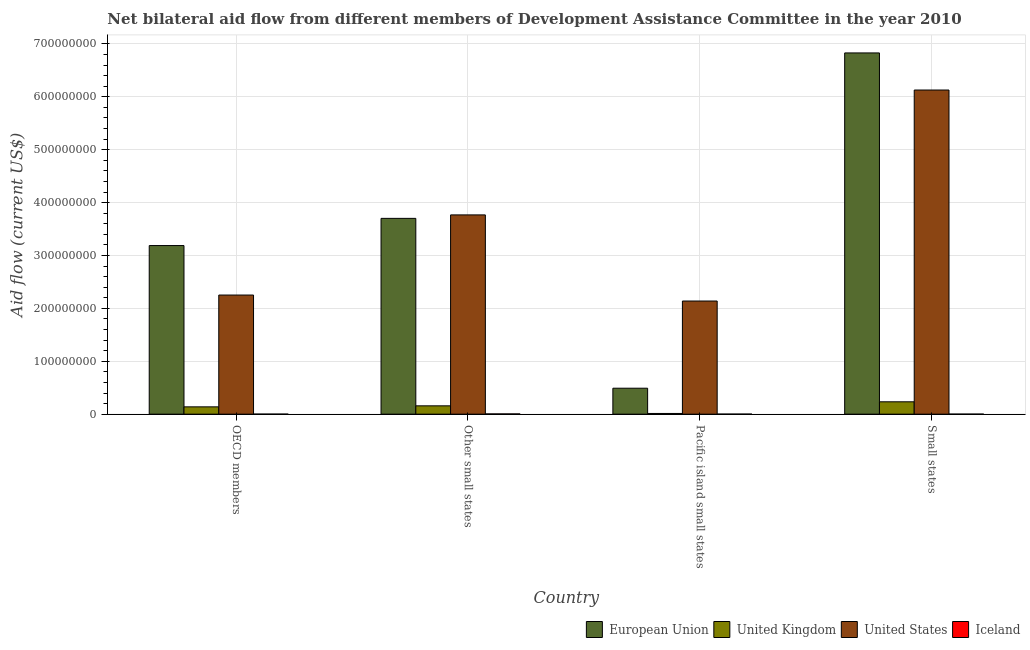How many different coloured bars are there?
Your answer should be compact. 4. How many groups of bars are there?
Ensure brevity in your answer.  4. Are the number of bars per tick equal to the number of legend labels?
Your answer should be compact. Yes. How many bars are there on the 2nd tick from the left?
Keep it short and to the point. 4. How many bars are there on the 2nd tick from the right?
Offer a terse response. 4. What is the label of the 4th group of bars from the left?
Your answer should be very brief. Small states. What is the amount of aid given by us in Pacific island small states?
Offer a very short reply. 2.14e+08. Across all countries, what is the maximum amount of aid given by us?
Ensure brevity in your answer.  6.13e+08. Across all countries, what is the minimum amount of aid given by uk?
Your answer should be compact. 1.34e+06. In which country was the amount of aid given by iceland maximum?
Make the answer very short. Other small states. In which country was the amount of aid given by uk minimum?
Your response must be concise. Pacific island small states. What is the total amount of aid given by uk in the graph?
Keep it short and to the point. 5.43e+07. What is the difference between the amount of aid given by uk in Pacific island small states and that in Small states?
Provide a short and direct response. -2.20e+07. What is the difference between the amount of aid given by us in Small states and the amount of aid given by eu in Pacific island small states?
Provide a short and direct response. 5.64e+08. What is the difference between the amount of aid given by eu and amount of aid given by uk in OECD members?
Give a very brief answer. 3.05e+08. What is the ratio of the amount of aid given by iceland in OECD members to that in Pacific island small states?
Make the answer very short. 0.67. What is the difference between the highest and the second highest amount of aid given by uk?
Give a very brief answer. 7.62e+06. What is the difference between the highest and the lowest amount of aid given by uk?
Offer a very short reply. 2.20e+07. In how many countries, is the amount of aid given by iceland greater than the average amount of aid given by iceland taken over all countries?
Provide a succinct answer. 1. Is the sum of the amount of aid given by iceland in OECD members and Small states greater than the maximum amount of aid given by uk across all countries?
Your answer should be very brief. No. What does the 2nd bar from the right in Other small states represents?
Make the answer very short. United States. Is it the case that in every country, the sum of the amount of aid given by eu and amount of aid given by uk is greater than the amount of aid given by us?
Make the answer very short. No. Are all the bars in the graph horizontal?
Provide a short and direct response. No. Are the values on the major ticks of Y-axis written in scientific E-notation?
Ensure brevity in your answer.  No. Does the graph contain any zero values?
Provide a short and direct response. No. Where does the legend appear in the graph?
Make the answer very short. Bottom right. What is the title of the graph?
Give a very brief answer. Net bilateral aid flow from different members of Development Assistance Committee in the year 2010. Does "Negligence towards children" appear as one of the legend labels in the graph?
Offer a very short reply. No. What is the label or title of the Y-axis?
Make the answer very short. Aid flow (current US$). What is the Aid flow (current US$) in European Union in OECD members?
Ensure brevity in your answer.  3.19e+08. What is the Aid flow (current US$) in United Kingdom in OECD members?
Your response must be concise. 1.38e+07. What is the Aid flow (current US$) in United States in OECD members?
Make the answer very short. 2.25e+08. What is the Aid flow (current US$) in European Union in Other small states?
Provide a short and direct response. 3.70e+08. What is the Aid flow (current US$) in United Kingdom in Other small states?
Keep it short and to the point. 1.57e+07. What is the Aid flow (current US$) in United States in Other small states?
Your response must be concise. 3.77e+08. What is the Aid flow (current US$) of European Union in Pacific island small states?
Your answer should be very brief. 4.91e+07. What is the Aid flow (current US$) in United Kingdom in Pacific island small states?
Your response must be concise. 1.34e+06. What is the Aid flow (current US$) of United States in Pacific island small states?
Your answer should be compact. 2.14e+08. What is the Aid flow (current US$) of European Union in Small states?
Provide a short and direct response. 6.83e+08. What is the Aid flow (current US$) of United Kingdom in Small states?
Offer a terse response. 2.34e+07. What is the Aid flow (current US$) of United States in Small states?
Make the answer very short. 6.13e+08. What is the Aid flow (current US$) of Iceland in Small states?
Your response must be concise. 9.00e+04. Across all countries, what is the maximum Aid flow (current US$) in European Union?
Give a very brief answer. 6.83e+08. Across all countries, what is the maximum Aid flow (current US$) of United Kingdom?
Ensure brevity in your answer.  2.34e+07. Across all countries, what is the maximum Aid flow (current US$) of United States?
Provide a short and direct response. 6.13e+08. Across all countries, what is the maximum Aid flow (current US$) in Iceland?
Give a very brief answer. 4.70e+05. Across all countries, what is the minimum Aid flow (current US$) of European Union?
Offer a very short reply. 4.91e+07. Across all countries, what is the minimum Aid flow (current US$) in United Kingdom?
Offer a very short reply. 1.34e+06. Across all countries, what is the minimum Aid flow (current US$) of United States?
Provide a succinct answer. 2.14e+08. What is the total Aid flow (current US$) in European Union in the graph?
Make the answer very short. 1.42e+09. What is the total Aid flow (current US$) in United Kingdom in the graph?
Make the answer very short. 5.43e+07. What is the total Aid flow (current US$) in United States in the graph?
Offer a terse response. 1.43e+09. What is the total Aid flow (current US$) in Iceland in the graph?
Keep it short and to the point. 7.60e+05. What is the difference between the Aid flow (current US$) in European Union in OECD members and that in Other small states?
Your answer should be very brief. -5.14e+07. What is the difference between the Aid flow (current US$) in United Kingdom in OECD members and that in Other small states?
Your response must be concise. -1.92e+06. What is the difference between the Aid flow (current US$) of United States in OECD members and that in Other small states?
Give a very brief answer. -1.52e+08. What is the difference between the Aid flow (current US$) of Iceland in OECD members and that in Other small states?
Keep it short and to the point. -3.90e+05. What is the difference between the Aid flow (current US$) of European Union in OECD members and that in Pacific island small states?
Provide a short and direct response. 2.70e+08. What is the difference between the Aid flow (current US$) of United Kingdom in OECD members and that in Pacific island small states?
Keep it short and to the point. 1.25e+07. What is the difference between the Aid flow (current US$) of United States in OECD members and that in Pacific island small states?
Give a very brief answer. 1.13e+07. What is the difference between the Aid flow (current US$) of Iceland in OECD members and that in Pacific island small states?
Provide a short and direct response. -4.00e+04. What is the difference between the Aid flow (current US$) of European Union in OECD members and that in Small states?
Offer a very short reply. -3.64e+08. What is the difference between the Aid flow (current US$) in United Kingdom in OECD members and that in Small states?
Make the answer very short. -9.54e+06. What is the difference between the Aid flow (current US$) in United States in OECD members and that in Small states?
Offer a very short reply. -3.88e+08. What is the difference between the Aid flow (current US$) of European Union in Other small states and that in Pacific island small states?
Make the answer very short. 3.21e+08. What is the difference between the Aid flow (current US$) of United Kingdom in Other small states and that in Pacific island small states?
Offer a terse response. 1.44e+07. What is the difference between the Aid flow (current US$) in United States in Other small states and that in Pacific island small states?
Give a very brief answer. 1.63e+08. What is the difference between the Aid flow (current US$) in European Union in Other small states and that in Small states?
Offer a terse response. -3.13e+08. What is the difference between the Aid flow (current US$) in United Kingdom in Other small states and that in Small states?
Give a very brief answer. -7.62e+06. What is the difference between the Aid flow (current US$) of United States in Other small states and that in Small states?
Your answer should be very brief. -2.36e+08. What is the difference between the Aid flow (current US$) of Iceland in Other small states and that in Small states?
Ensure brevity in your answer.  3.80e+05. What is the difference between the Aid flow (current US$) of European Union in Pacific island small states and that in Small states?
Provide a short and direct response. -6.34e+08. What is the difference between the Aid flow (current US$) of United Kingdom in Pacific island small states and that in Small states?
Your answer should be compact. -2.20e+07. What is the difference between the Aid flow (current US$) of United States in Pacific island small states and that in Small states?
Offer a terse response. -3.99e+08. What is the difference between the Aid flow (current US$) of European Union in OECD members and the Aid flow (current US$) of United Kingdom in Other small states?
Provide a succinct answer. 3.03e+08. What is the difference between the Aid flow (current US$) in European Union in OECD members and the Aid flow (current US$) in United States in Other small states?
Offer a very short reply. -5.80e+07. What is the difference between the Aid flow (current US$) in European Union in OECD members and the Aid flow (current US$) in Iceland in Other small states?
Ensure brevity in your answer.  3.18e+08. What is the difference between the Aid flow (current US$) of United Kingdom in OECD members and the Aid flow (current US$) of United States in Other small states?
Give a very brief answer. -3.63e+08. What is the difference between the Aid flow (current US$) in United Kingdom in OECD members and the Aid flow (current US$) in Iceland in Other small states?
Make the answer very short. 1.34e+07. What is the difference between the Aid flow (current US$) of United States in OECD members and the Aid flow (current US$) of Iceland in Other small states?
Your response must be concise. 2.25e+08. What is the difference between the Aid flow (current US$) of European Union in OECD members and the Aid flow (current US$) of United Kingdom in Pacific island small states?
Ensure brevity in your answer.  3.17e+08. What is the difference between the Aid flow (current US$) in European Union in OECD members and the Aid flow (current US$) in United States in Pacific island small states?
Offer a very short reply. 1.05e+08. What is the difference between the Aid flow (current US$) in European Union in OECD members and the Aid flow (current US$) in Iceland in Pacific island small states?
Your answer should be compact. 3.19e+08. What is the difference between the Aid flow (current US$) of United Kingdom in OECD members and the Aid flow (current US$) of United States in Pacific island small states?
Your answer should be very brief. -2.00e+08. What is the difference between the Aid flow (current US$) of United Kingdom in OECD members and the Aid flow (current US$) of Iceland in Pacific island small states?
Make the answer very short. 1.37e+07. What is the difference between the Aid flow (current US$) in United States in OECD members and the Aid flow (current US$) in Iceland in Pacific island small states?
Your response must be concise. 2.25e+08. What is the difference between the Aid flow (current US$) in European Union in OECD members and the Aid flow (current US$) in United Kingdom in Small states?
Your response must be concise. 2.95e+08. What is the difference between the Aid flow (current US$) in European Union in OECD members and the Aid flow (current US$) in United States in Small states?
Your answer should be very brief. -2.94e+08. What is the difference between the Aid flow (current US$) of European Union in OECD members and the Aid flow (current US$) of Iceland in Small states?
Offer a very short reply. 3.19e+08. What is the difference between the Aid flow (current US$) in United Kingdom in OECD members and the Aid flow (current US$) in United States in Small states?
Your answer should be compact. -5.99e+08. What is the difference between the Aid flow (current US$) in United Kingdom in OECD members and the Aid flow (current US$) in Iceland in Small states?
Your answer should be compact. 1.37e+07. What is the difference between the Aid flow (current US$) in United States in OECD members and the Aid flow (current US$) in Iceland in Small states?
Make the answer very short. 2.25e+08. What is the difference between the Aid flow (current US$) of European Union in Other small states and the Aid flow (current US$) of United Kingdom in Pacific island small states?
Ensure brevity in your answer.  3.69e+08. What is the difference between the Aid flow (current US$) in European Union in Other small states and the Aid flow (current US$) in United States in Pacific island small states?
Make the answer very short. 1.56e+08. What is the difference between the Aid flow (current US$) of European Union in Other small states and the Aid flow (current US$) of Iceland in Pacific island small states?
Provide a succinct answer. 3.70e+08. What is the difference between the Aid flow (current US$) of United Kingdom in Other small states and the Aid flow (current US$) of United States in Pacific island small states?
Provide a short and direct response. -1.98e+08. What is the difference between the Aid flow (current US$) in United Kingdom in Other small states and the Aid flow (current US$) in Iceland in Pacific island small states?
Offer a terse response. 1.56e+07. What is the difference between the Aid flow (current US$) in United States in Other small states and the Aid flow (current US$) in Iceland in Pacific island small states?
Keep it short and to the point. 3.77e+08. What is the difference between the Aid flow (current US$) of European Union in Other small states and the Aid flow (current US$) of United Kingdom in Small states?
Provide a succinct answer. 3.47e+08. What is the difference between the Aid flow (current US$) of European Union in Other small states and the Aid flow (current US$) of United States in Small states?
Give a very brief answer. -2.43e+08. What is the difference between the Aid flow (current US$) of European Union in Other small states and the Aid flow (current US$) of Iceland in Small states?
Offer a terse response. 3.70e+08. What is the difference between the Aid flow (current US$) of United Kingdom in Other small states and the Aid flow (current US$) of United States in Small states?
Offer a terse response. -5.97e+08. What is the difference between the Aid flow (current US$) in United Kingdom in Other small states and the Aid flow (current US$) in Iceland in Small states?
Make the answer very short. 1.56e+07. What is the difference between the Aid flow (current US$) in United States in Other small states and the Aid flow (current US$) in Iceland in Small states?
Offer a terse response. 3.77e+08. What is the difference between the Aid flow (current US$) in European Union in Pacific island small states and the Aid flow (current US$) in United Kingdom in Small states?
Your answer should be compact. 2.57e+07. What is the difference between the Aid flow (current US$) of European Union in Pacific island small states and the Aid flow (current US$) of United States in Small states?
Provide a succinct answer. -5.64e+08. What is the difference between the Aid flow (current US$) of European Union in Pacific island small states and the Aid flow (current US$) of Iceland in Small states?
Offer a terse response. 4.90e+07. What is the difference between the Aid flow (current US$) in United Kingdom in Pacific island small states and the Aid flow (current US$) in United States in Small states?
Offer a terse response. -6.12e+08. What is the difference between the Aid flow (current US$) of United Kingdom in Pacific island small states and the Aid flow (current US$) of Iceland in Small states?
Provide a succinct answer. 1.25e+06. What is the difference between the Aid flow (current US$) of United States in Pacific island small states and the Aid flow (current US$) of Iceland in Small states?
Give a very brief answer. 2.14e+08. What is the average Aid flow (current US$) of European Union per country?
Offer a terse response. 3.55e+08. What is the average Aid flow (current US$) in United Kingdom per country?
Ensure brevity in your answer.  1.36e+07. What is the average Aid flow (current US$) of United States per country?
Offer a terse response. 3.57e+08. What is the difference between the Aid flow (current US$) in European Union and Aid flow (current US$) in United Kingdom in OECD members?
Make the answer very short. 3.05e+08. What is the difference between the Aid flow (current US$) of European Union and Aid flow (current US$) of United States in OECD members?
Your response must be concise. 9.36e+07. What is the difference between the Aid flow (current US$) in European Union and Aid flow (current US$) in Iceland in OECD members?
Your response must be concise. 3.19e+08. What is the difference between the Aid flow (current US$) of United Kingdom and Aid flow (current US$) of United States in OECD members?
Your answer should be very brief. -2.11e+08. What is the difference between the Aid flow (current US$) of United Kingdom and Aid flow (current US$) of Iceland in OECD members?
Your answer should be very brief. 1.37e+07. What is the difference between the Aid flow (current US$) in United States and Aid flow (current US$) in Iceland in OECD members?
Your response must be concise. 2.25e+08. What is the difference between the Aid flow (current US$) in European Union and Aid flow (current US$) in United Kingdom in Other small states?
Your answer should be compact. 3.54e+08. What is the difference between the Aid flow (current US$) of European Union and Aid flow (current US$) of United States in Other small states?
Make the answer very short. -6.56e+06. What is the difference between the Aid flow (current US$) of European Union and Aid flow (current US$) of Iceland in Other small states?
Keep it short and to the point. 3.70e+08. What is the difference between the Aid flow (current US$) of United Kingdom and Aid flow (current US$) of United States in Other small states?
Your answer should be compact. -3.61e+08. What is the difference between the Aid flow (current US$) in United Kingdom and Aid flow (current US$) in Iceland in Other small states?
Keep it short and to the point. 1.53e+07. What is the difference between the Aid flow (current US$) of United States and Aid flow (current US$) of Iceland in Other small states?
Keep it short and to the point. 3.76e+08. What is the difference between the Aid flow (current US$) in European Union and Aid flow (current US$) in United Kingdom in Pacific island small states?
Keep it short and to the point. 4.77e+07. What is the difference between the Aid flow (current US$) of European Union and Aid flow (current US$) of United States in Pacific island small states?
Your answer should be compact. -1.65e+08. What is the difference between the Aid flow (current US$) in European Union and Aid flow (current US$) in Iceland in Pacific island small states?
Ensure brevity in your answer.  4.89e+07. What is the difference between the Aid flow (current US$) in United Kingdom and Aid flow (current US$) in United States in Pacific island small states?
Offer a very short reply. -2.13e+08. What is the difference between the Aid flow (current US$) of United Kingdom and Aid flow (current US$) of Iceland in Pacific island small states?
Provide a short and direct response. 1.22e+06. What is the difference between the Aid flow (current US$) in United States and Aid flow (current US$) in Iceland in Pacific island small states?
Offer a terse response. 2.14e+08. What is the difference between the Aid flow (current US$) in European Union and Aid flow (current US$) in United Kingdom in Small states?
Your response must be concise. 6.60e+08. What is the difference between the Aid flow (current US$) in European Union and Aid flow (current US$) in United States in Small states?
Offer a very short reply. 7.01e+07. What is the difference between the Aid flow (current US$) of European Union and Aid flow (current US$) of Iceland in Small states?
Provide a succinct answer. 6.83e+08. What is the difference between the Aid flow (current US$) of United Kingdom and Aid flow (current US$) of United States in Small states?
Provide a succinct answer. -5.90e+08. What is the difference between the Aid flow (current US$) in United Kingdom and Aid flow (current US$) in Iceland in Small states?
Keep it short and to the point. 2.33e+07. What is the difference between the Aid flow (current US$) of United States and Aid flow (current US$) of Iceland in Small states?
Provide a succinct answer. 6.13e+08. What is the ratio of the Aid flow (current US$) of European Union in OECD members to that in Other small states?
Ensure brevity in your answer.  0.86. What is the ratio of the Aid flow (current US$) in United Kingdom in OECD members to that in Other small states?
Ensure brevity in your answer.  0.88. What is the ratio of the Aid flow (current US$) of United States in OECD members to that in Other small states?
Give a very brief answer. 0.6. What is the ratio of the Aid flow (current US$) of Iceland in OECD members to that in Other small states?
Your answer should be compact. 0.17. What is the ratio of the Aid flow (current US$) of European Union in OECD members to that in Pacific island small states?
Provide a succinct answer. 6.5. What is the ratio of the Aid flow (current US$) in United Kingdom in OECD members to that in Pacific island small states?
Your answer should be very brief. 10.31. What is the ratio of the Aid flow (current US$) in United States in OECD members to that in Pacific island small states?
Offer a terse response. 1.05. What is the ratio of the Aid flow (current US$) in Iceland in OECD members to that in Pacific island small states?
Provide a succinct answer. 0.67. What is the ratio of the Aid flow (current US$) in European Union in OECD members to that in Small states?
Make the answer very short. 0.47. What is the ratio of the Aid flow (current US$) of United Kingdom in OECD members to that in Small states?
Give a very brief answer. 0.59. What is the ratio of the Aid flow (current US$) of United States in OECD members to that in Small states?
Provide a short and direct response. 0.37. What is the ratio of the Aid flow (current US$) in Iceland in OECD members to that in Small states?
Provide a short and direct response. 0.89. What is the ratio of the Aid flow (current US$) of European Union in Other small states to that in Pacific island small states?
Provide a succinct answer. 7.55. What is the ratio of the Aid flow (current US$) of United Kingdom in Other small states to that in Pacific island small states?
Make the answer very short. 11.75. What is the ratio of the Aid flow (current US$) in United States in Other small states to that in Pacific island small states?
Your answer should be compact. 1.76. What is the ratio of the Aid flow (current US$) of Iceland in Other small states to that in Pacific island small states?
Your answer should be compact. 3.92. What is the ratio of the Aid flow (current US$) of European Union in Other small states to that in Small states?
Ensure brevity in your answer.  0.54. What is the ratio of the Aid flow (current US$) of United Kingdom in Other small states to that in Small states?
Your response must be concise. 0.67. What is the ratio of the Aid flow (current US$) of United States in Other small states to that in Small states?
Keep it short and to the point. 0.61. What is the ratio of the Aid flow (current US$) in Iceland in Other small states to that in Small states?
Offer a very short reply. 5.22. What is the ratio of the Aid flow (current US$) of European Union in Pacific island small states to that in Small states?
Keep it short and to the point. 0.07. What is the ratio of the Aid flow (current US$) of United Kingdom in Pacific island small states to that in Small states?
Offer a very short reply. 0.06. What is the ratio of the Aid flow (current US$) in United States in Pacific island small states to that in Small states?
Offer a terse response. 0.35. What is the ratio of the Aid flow (current US$) of Iceland in Pacific island small states to that in Small states?
Provide a short and direct response. 1.33. What is the difference between the highest and the second highest Aid flow (current US$) of European Union?
Offer a terse response. 3.13e+08. What is the difference between the highest and the second highest Aid flow (current US$) in United Kingdom?
Make the answer very short. 7.62e+06. What is the difference between the highest and the second highest Aid flow (current US$) in United States?
Ensure brevity in your answer.  2.36e+08. What is the difference between the highest and the second highest Aid flow (current US$) in Iceland?
Ensure brevity in your answer.  3.50e+05. What is the difference between the highest and the lowest Aid flow (current US$) in European Union?
Offer a very short reply. 6.34e+08. What is the difference between the highest and the lowest Aid flow (current US$) in United Kingdom?
Provide a short and direct response. 2.20e+07. What is the difference between the highest and the lowest Aid flow (current US$) of United States?
Make the answer very short. 3.99e+08. 